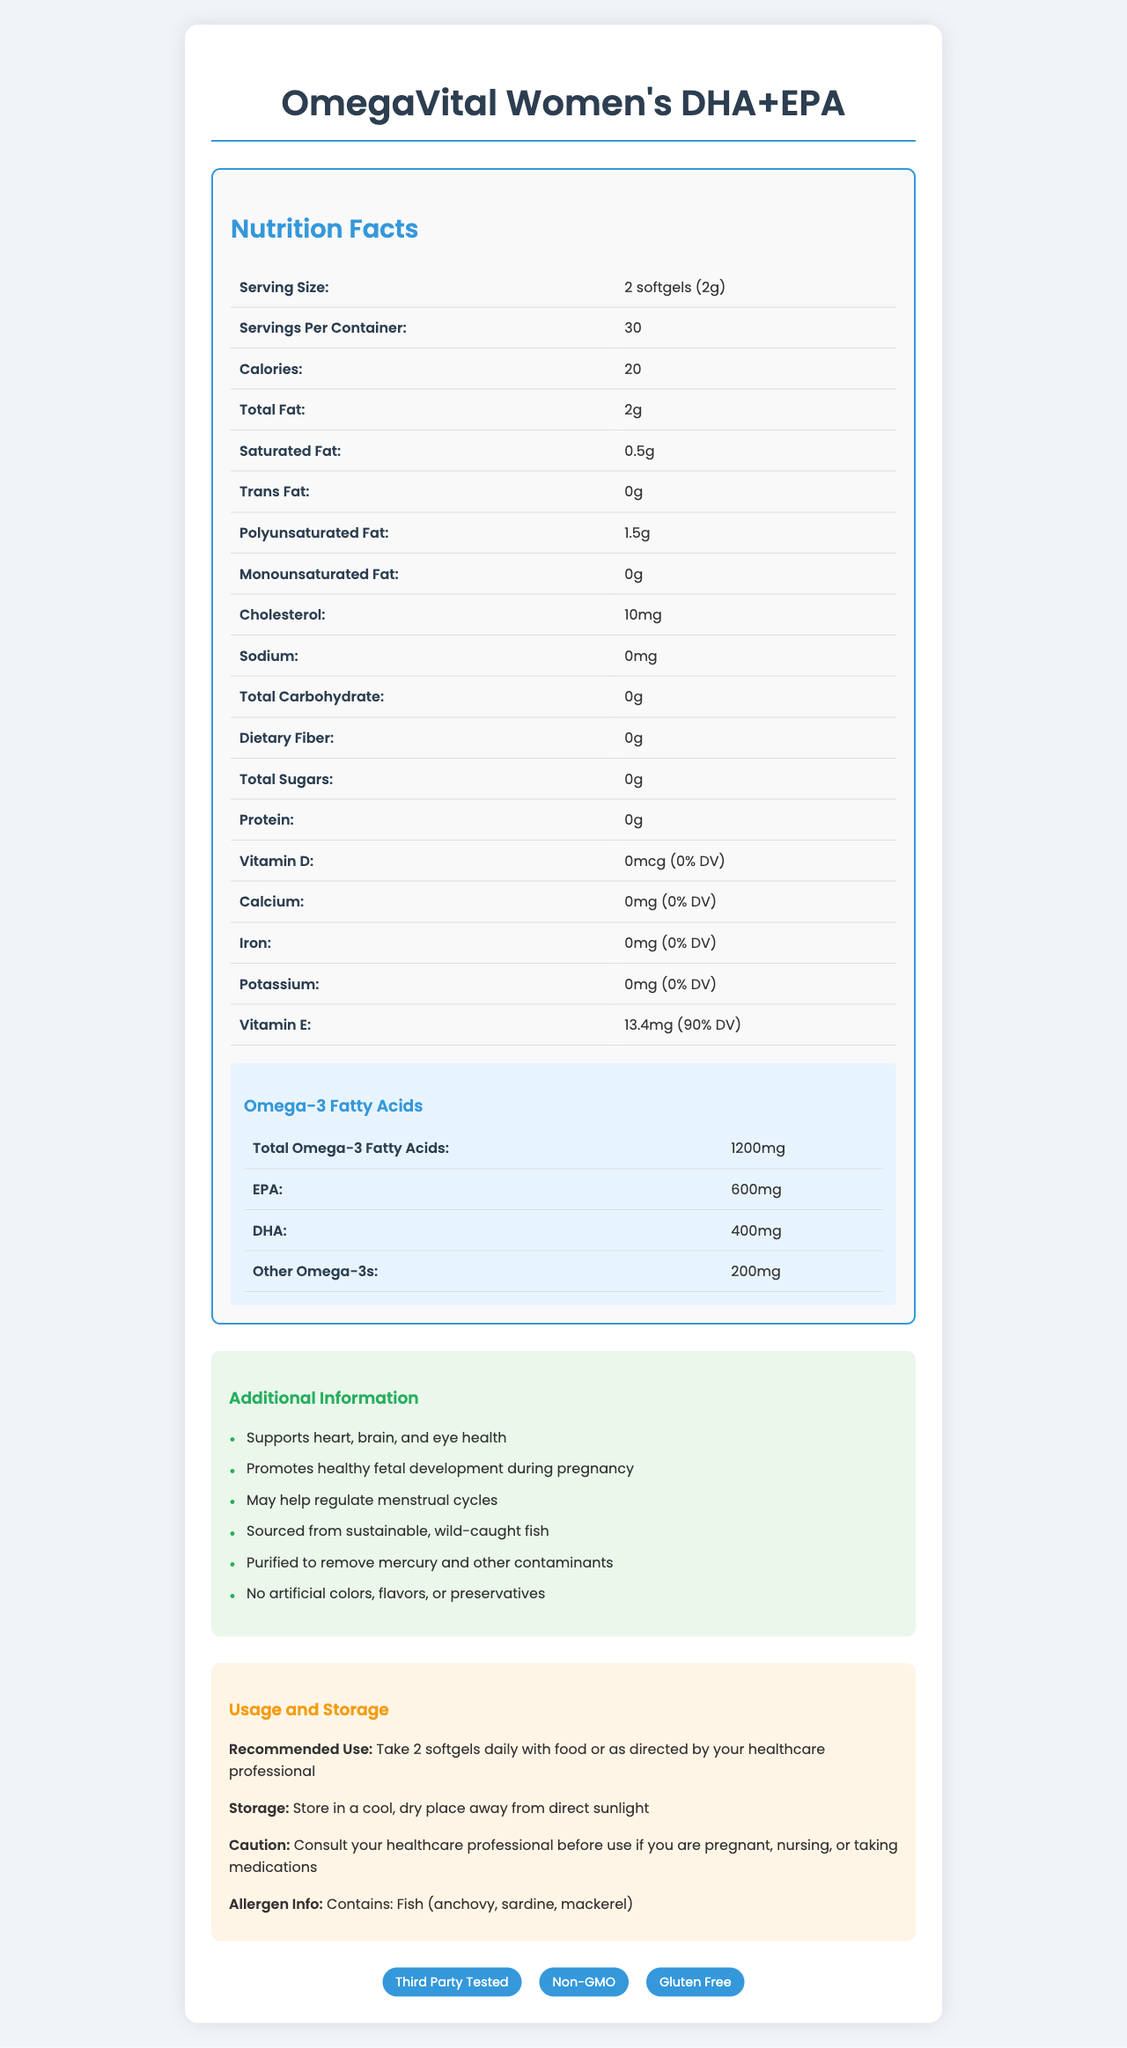what is the serving size? The serving size information is directly mentioned in the Nutrition Facts section of the document.
Answer: 2 softgels (2g) how many servings are there per container? The number of servings per container is clearly listed in the Nutrition Facts section.
Answer: 30 what is the total amount of omega-3 fatty acids per serving? The total omega-3 fatty acids per serving is specified in the Omega-3 Fatty Acids breakdown.
Answer: 1200mg how many calories does each serving contain? The calorie count per serving is indicated in the Nutrition Facts section.
Answer: 20 how much Vitamin E is in each serving, and what percentage of the daily value does it represent? The amount of Vitamin E and its percentage of the daily value is mentioned in the Nutrition Facts section under Vitamin E.
Answer: 13.4mg (90% DV) which types of fish are included in this supplement? A. Salmon, Tuna, Cod B. Anchovy, Sardine, Mackerel C. Haddock, Halibut, Trout The allergen information specifies that the product contains fish, including anchovy, sardine, and mackerel.
Answer: B. Anchovy, Sardine, Mackerel what is the recommended daily usage of this supplement? A. 1 softgel B. 2 softgels C. 3 softgels The recommended use is to take 2 softgels daily as mentioned in the Usage and Storage section.
Answer: B. 2 softgels does this product contain any artificial colors or preservatives? The additional information states that the product contains no artificial colors, flavors, or preservatives.
Answer: No is it safe to use this supplement without consulting a healthcare professional if you are pregnant or nursing? The caution section advises consulting with a healthcare professional before use if pregnant or nursing.
Answer: No summarize the key benefits and features of this omega-3 supplement. The additional information lists the key benefits and features, such as supporting various health aspects, promoting fetal development, regulating menstrual cycles, sourcing from sustainable fish, and being purified to remove contaminants.
Answer: Supports heart, brain, and eye health; Promotes healthy fetal development during pregnancy; May help regulate menstrual cycles; Sourced from sustainable, wild-caught fish; Purified to remove mercury and other contaminants. how many mg of DHA are present in one serving of this supplement? The amount of DHA is listed under the Omega-3 Fatty Acids breakdown.
Answer: 400mg what is the total fat content per serving, and how much of it is polyunsaturated fat? The total fat content and the amount of polyunsaturated fat are indicated in the Nutrition Facts section.
Answer: 2g, 1.5g how should this supplement be stored? The storage instructions are part of the Usage and Storage section.
Answer: In a cool, dry place away from direct sunlight does the product contain any Vitamin D? According to the Nutrition Facts section, the product contains 0mcg of Vitamin D, which is 0% of the daily value.
Answer: No how much protein is in one serving of this supplement? The protein content per serving is listed as 0g in the Nutrition Facts section.
Answer: 0g is this omega-3 supplement third-party tested? The certifications section confirms that the product is third-party tested.
Answer: Yes what brand manufactures this omega-3 supplement? The document provides detailed nutritional information and benefits but does not mention the brand that manufactures the product.
Answer: Cannot be determined 